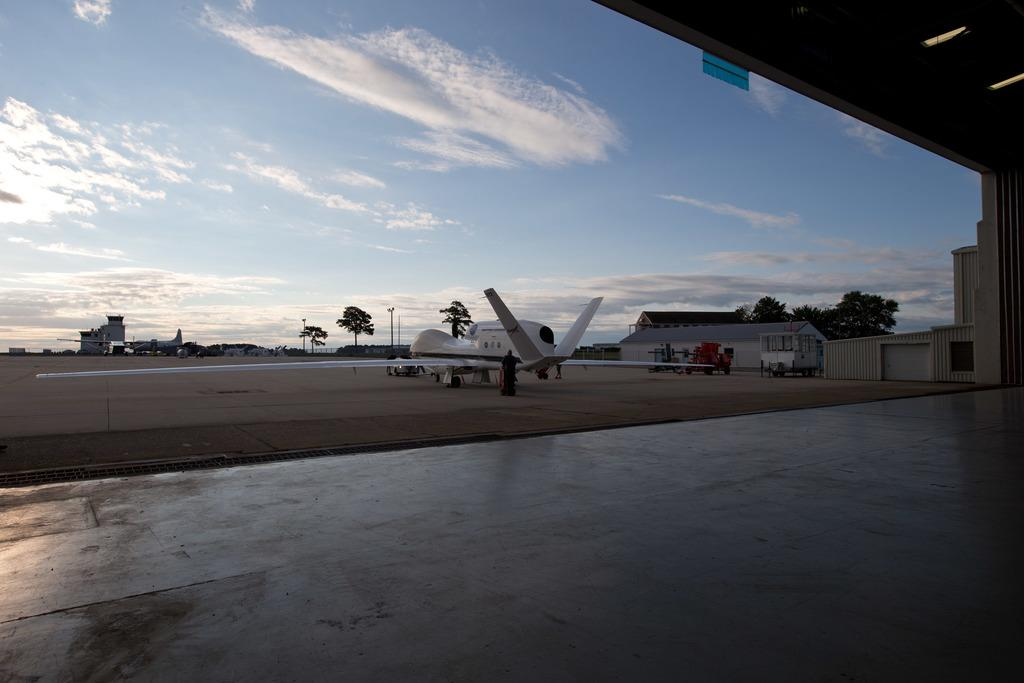What type of transportation can be seen in the image? There are airplanes and vehicles in the image. What type of structures are present in the image? There are sheds in the image. What type of natural elements are present in the image? There are trees in the image. What type of man-made structures are present in the image? There are poles in the image. What can be seen in the background of the image? The sky is visible in the background of the image. How many buttons are on the airplane in the image? There are no buttons visible on the airplanes in the image. What type of care is being provided to the trees in the image? There is no indication of care being provided to the trees in the image; they are simply present in the image. 